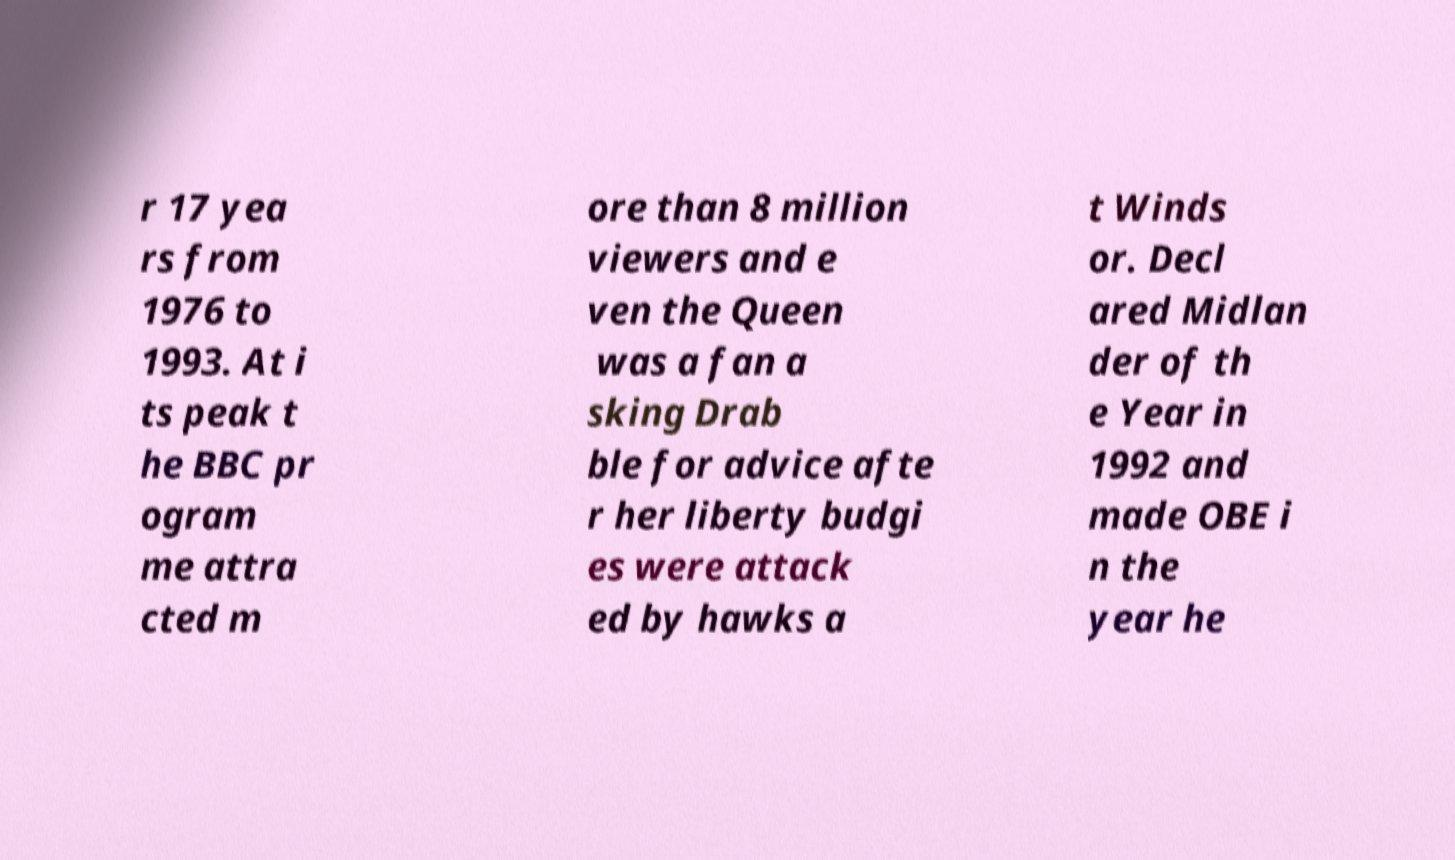Can you accurately transcribe the text from the provided image for me? r 17 yea rs from 1976 to 1993. At i ts peak t he BBC pr ogram me attra cted m ore than 8 million viewers and e ven the Queen was a fan a sking Drab ble for advice afte r her liberty budgi es were attack ed by hawks a t Winds or. Decl ared Midlan der of th e Year in 1992 and made OBE i n the year he 